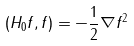Convert formula to latex. <formula><loc_0><loc_0><loc_500><loc_500>( H _ { 0 } f , f ) = - \frac { 1 } { 2 } \| \nabla f \| ^ { 2 }</formula> 